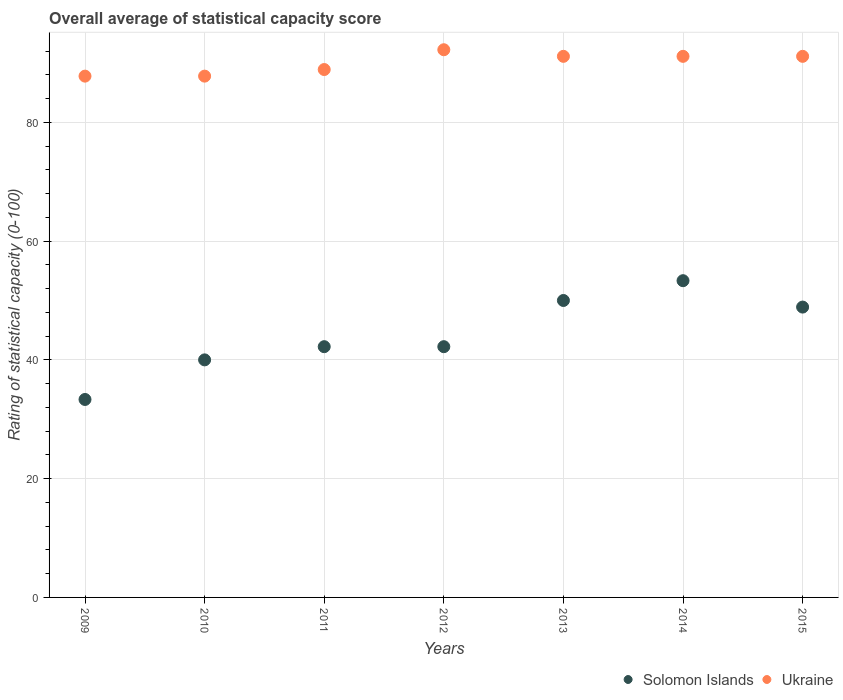What is the rating of statistical capacity in Solomon Islands in 2014?
Your answer should be very brief. 53.33. Across all years, what is the maximum rating of statistical capacity in Solomon Islands?
Provide a short and direct response. 53.33. Across all years, what is the minimum rating of statistical capacity in Ukraine?
Offer a very short reply. 87.78. In which year was the rating of statistical capacity in Solomon Islands maximum?
Make the answer very short. 2014. In which year was the rating of statistical capacity in Solomon Islands minimum?
Your response must be concise. 2009. What is the total rating of statistical capacity in Solomon Islands in the graph?
Provide a succinct answer. 310. What is the difference between the rating of statistical capacity in Solomon Islands in 2011 and that in 2013?
Your answer should be compact. -7.78. What is the difference between the rating of statistical capacity in Ukraine in 2013 and the rating of statistical capacity in Solomon Islands in 2012?
Keep it short and to the point. 48.89. What is the average rating of statistical capacity in Ukraine per year?
Keep it short and to the point. 90. In the year 2010, what is the difference between the rating of statistical capacity in Ukraine and rating of statistical capacity in Solomon Islands?
Ensure brevity in your answer.  47.78. What is the ratio of the rating of statistical capacity in Solomon Islands in 2011 to that in 2014?
Give a very brief answer. 0.79. What is the difference between the highest and the second highest rating of statistical capacity in Solomon Islands?
Provide a short and direct response. 3.33. What is the difference between the highest and the lowest rating of statistical capacity in Solomon Islands?
Keep it short and to the point. 20. In how many years, is the rating of statistical capacity in Ukraine greater than the average rating of statistical capacity in Ukraine taken over all years?
Your answer should be very brief. 4. Is the sum of the rating of statistical capacity in Solomon Islands in 2010 and 2013 greater than the maximum rating of statistical capacity in Ukraine across all years?
Offer a terse response. No. Is the rating of statistical capacity in Ukraine strictly less than the rating of statistical capacity in Solomon Islands over the years?
Give a very brief answer. No. How many dotlines are there?
Make the answer very short. 2. Are the values on the major ticks of Y-axis written in scientific E-notation?
Keep it short and to the point. No. Does the graph contain any zero values?
Give a very brief answer. No. What is the title of the graph?
Offer a very short reply. Overall average of statistical capacity score. What is the label or title of the X-axis?
Provide a short and direct response. Years. What is the label or title of the Y-axis?
Ensure brevity in your answer.  Rating of statistical capacity (0-100). What is the Rating of statistical capacity (0-100) in Solomon Islands in 2009?
Offer a terse response. 33.33. What is the Rating of statistical capacity (0-100) in Ukraine in 2009?
Your answer should be very brief. 87.78. What is the Rating of statistical capacity (0-100) in Solomon Islands in 2010?
Offer a terse response. 40. What is the Rating of statistical capacity (0-100) in Ukraine in 2010?
Provide a short and direct response. 87.78. What is the Rating of statistical capacity (0-100) in Solomon Islands in 2011?
Your answer should be very brief. 42.22. What is the Rating of statistical capacity (0-100) in Ukraine in 2011?
Your answer should be compact. 88.89. What is the Rating of statistical capacity (0-100) in Solomon Islands in 2012?
Provide a short and direct response. 42.22. What is the Rating of statistical capacity (0-100) in Ukraine in 2012?
Keep it short and to the point. 92.22. What is the Rating of statistical capacity (0-100) in Ukraine in 2013?
Your response must be concise. 91.11. What is the Rating of statistical capacity (0-100) of Solomon Islands in 2014?
Your answer should be compact. 53.33. What is the Rating of statistical capacity (0-100) in Ukraine in 2014?
Offer a terse response. 91.11. What is the Rating of statistical capacity (0-100) in Solomon Islands in 2015?
Ensure brevity in your answer.  48.89. What is the Rating of statistical capacity (0-100) of Ukraine in 2015?
Your answer should be compact. 91.11. Across all years, what is the maximum Rating of statistical capacity (0-100) in Solomon Islands?
Keep it short and to the point. 53.33. Across all years, what is the maximum Rating of statistical capacity (0-100) of Ukraine?
Keep it short and to the point. 92.22. Across all years, what is the minimum Rating of statistical capacity (0-100) in Solomon Islands?
Provide a short and direct response. 33.33. Across all years, what is the minimum Rating of statistical capacity (0-100) in Ukraine?
Provide a succinct answer. 87.78. What is the total Rating of statistical capacity (0-100) of Solomon Islands in the graph?
Your response must be concise. 310. What is the total Rating of statistical capacity (0-100) in Ukraine in the graph?
Give a very brief answer. 630. What is the difference between the Rating of statistical capacity (0-100) of Solomon Islands in 2009 and that in 2010?
Your answer should be very brief. -6.67. What is the difference between the Rating of statistical capacity (0-100) of Ukraine in 2009 and that in 2010?
Your response must be concise. 0. What is the difference between the Rating of statistical capacity (0-100) in Solomon Islands in 2009 and that in 2011?
Make the answer very short. -8.89. What is the difference between the Rating of statistical capacity (0-100) in Ukraine in 2009 and that in 2011?
Give a very brief answer. -1.11. What is the difference between the Rating of statistical capacity (0-100) of Solomon Islands in 2009 and that in 2012?
Keep it short and to the point. -8.89. What is the difference between the Rating of statistical capacity (0-100) of Ukraine in 2009 and that in 2012?
Provide a short and direct response. -4.44. What is the difference between the Rating of statistical capacity (0-100) of Solomon Islands in 2009 and that in 2013?
Offer a terse response. -16.67. What is the difference between the Rating of statistical capacity (0-100) of Solomon Islands in 2009 and that in 2014?
Make the answer very short. -20. What is the difference between the Rating of statistical capacity (0-100) in Solomon Islands in 2009 and that in 2015?
Give a very brief answer. -15.56. What is the difference between the Rating of statistical capacity (0-100) of Solomon Islands in 2010 and that in 2011?
Your answer should be compact. -2.22. What is the difference between the Rating of statistical capacity (0-100) of Ukraine in 2010 and that in 2011?
Make the answer very short. -1.11. What is the difference between the Rating of statistical capacity (0-100) in Solomon Islands in 2010 and that in 2012?
Offer a terse response. -2.22. What is the difference between the Rating of statistical capacity (0-100) of Ukraine in 2010 and that in 2012?
Your answer should be compact. -4.44. What is the difference between the Rating of statistical capacity (0-100) of Solomon Islands in 2010 and that in 2014?
Your response must be concise. -13.33. What is the difference between the Rating of statistical capacity (0-100) in Solomon Islands in 2010 and that in 2015?
Make the answer very short. -8.89. What is the difference between the Rating of statistical capacity (0-100) of Ukraine in 2010 and that in 2015?
Offer a very short reply. -3.33. What is the difference between the Rating of statistical capacity (0-100) in Solomon Islands in 2011 and that in 2013?
Provide a succinct answer. -7.78. What is the difference between the Rating of statistical capacity (0-100) of Ukraine in 2011 and that in 2013?
Offer a terse response. -2.22. What is the difference between the Rating of statistical capacity (0-100) in Solomon Islands in 2011 and that in 2014?
Your answer should be compact. -11.11. What is the difference between the Rating of statistical capacity (0-100) in Ukraine in 2011 and that in 2014?
Keep it short and to the point. -2.22. What is the difference between the Rating of statistical capacity (0-100) in Solomon Islands in 2011 and that in 2015?
Ensure brevity in your answer.  -6.67. What is the difference between the Rating of statistical capacity (0-100) of Ukraine in 2011 and that in 2015?
Make the answer very short. -2.22. What is the difference between the Rating of statistical capacity (0-100) of Solomon Islands in 2012 and that in 2013?
Your response must be concise. -7.78. What is the difference between the Rating of statistical capacity (0-100) in Ukraine in 2012 and that in 2013?
Offer a terse response. 1.11. What is the difference between the Rating of statistical capacity (0-100) in Solomon Islands in 2012 and that in 2014?
Offer a terse response. -11.11. What is the difference between the Rating of statistical capacity (0-100) in Solomon Islands in 2012 and that in 2015?
Keep it short and to the point. -6.67. What is the difference between the Rating of statistical capacity (0-100) in Ukraine in 2012 and that in 2015?
Provide a short and direct response. 1.11. What is the difference between the Rating of statistical capacity (0-100) of Solomon Islands in 2013 and that in 2014?
Provide a short and direct response. -3.33. What is the difference between the Rating of statistical capacity (0-100) of Solomon Islands in 2013 and that in 2015?
Offer a terse response. 1.11. What is the difference between the Rating of statistical capacity (0-100) in Solomon Islands in 2014 and that in 2015?
Give a very brief answer. 4.44. What is the difference between the Rating of statistical capacity (0-100) in Solomon Islands in 2009 and the Rating of statistical capacity (0-100) in Ukraine in 2010?
Make the answer very short. -54.44. What is the difference between the Rating of statistical capacity (0-100) in Solomon Islands in 2009 and the Rating of statistical capacity (0-100) in Ukraine in 2011?
Keep it short and to the point. -55.56. What is the difference between the Rating of statistical capacity (0-100) in Solomon Islands in 2009 and the Rating of statistical capacity (0-100) in Ukraine in 2012?
Your response must be concise. -58.89. What is the difference between the Rating of statistical capacity (0-100) of Solomon Islands in 2009 and the Rating of statistical capacity (0-100) of Ukraine in 2013?
Provide a short and direct response. -57.78. What is the difference between the Rating of statistical capacity (0-100) in Solomon Islands in 2009 and the Rating of statistical capacity (0-100) in Ukraine in 2014?
Your answer should be very brief. -57.78. What is the difference between the Rating of statistical capacity (0-100) in Solomon Islands in 2009 and the Rating of statistical capacity (0-100) in Ukraine in 2015?
Offer a terse response. -57.78. What is the difference between the Rating of statistical capacity (0-100) of Solomon Islands in 2010 and the Rating of statistical capacity (0-100) of Ukraine in 2011?
Your response must be concise. -48.89. What is the difference between the Rating of statistical capacity (0-100) in Solomon Islands in 2010 and the Rating of statistical capacity (0-100) in Ukraine in 2012?
Provide a succinct answer. -52.22. What is the difference between the Rating of statistical capacity (0-100) of Solomon Islands in 2010 and the Rating of statistical capacity (0-100) of Ukraine in 2013?
Your answer should be very brief. -51.11. What is the difference between the Rating of statistical capacity (0-100) in Solomon Islands in 2010 and the Rating of statistical capacity (0-100) in Ukraine in 2014?
Your answer should be compact. -51.11. What is the difference between the Rating of statistical capacity (0-100) of Solomon Islands in 2010 and the Rating of statistical capacity (0-100) of Ukraine in 2015?
Offer a terse response. -51.11. What is the difference between the Rating of statistical capacity (0-100) in Solomon Islands in 2011 and the Rating of statistical capacity (0-100) in Ukraine in 2012?
Give a very brief answer. -50. What is the difference between the Rating of statistical capacity (0-100) of Solomon Islands in 2011 and the Rating of statistical capacity (0-100) of Ukraine in 2013?
Offer a terse response. -48.89. What is the difference between the Rating of statistical capacity (0-100) in Solomon Islands in 2011 and the Rating of statistical capacity (0-100) in Ukraine in 2014?
Ensure brevity in your answer.  -48.89. What is the difference between the Rating of statistical capacity (0-100) of Solomon Islands in 2011 and the Rating of statistical capacity (0-100) of Ukraine in 2015?
Your answer should be very brief. -48.89. What is the difference between the Rating of statistical capacity (0-100) of Solomon Islands in 2012 and the Rating of statistical capacity (0-100) of Ukraine in 2013?
Provide a succinct answer. -48.89. What is the difference between the Rating of statistical capacity (0-100) in Solomon Islands in 2012 and the Rating of statistical capacity (0-100) in Ukraine in 2014?
Keep it short and to the point. -48.89. What is the difference between the Rating of statistical capacity (0-100) of Solomon Islands in 2012 and the Rating of statistical capacity (0-100) of Ukraine in 2015?
Provide a succinct answer. -48.89. What is the difference between the Rating of statistical capacity (0-100) in Solomon Islands in 2013 and the Rating of statistical capacity (0-100) in Ukraine in 2014?
Keep it short and to the point. -41.11. What is the difference between the Rating of statistical capacity (0-100) of Solomon Islands in 2013 and the Rating of statistical capacity (0-100) of Ukraine in 2015?
Offer a very short reply. -41.11. What is the difference between the Rating of statistical capacity (0-100) of Solomon Islands in 2014 and the Rating of statistical capacity (0-100) of Ukraine in 2015?
Provide a succinct answer. -37.78. What is the average Rating of statistical capacity (0-100) in Solomon Islands per year?
Offer a terse response. 44.29. In the year 2009, what is the difference between the Rating of statistical capacity (0-100) of Solomon Islands and Rating of statistical capacity (0-100) of Ukraine?
Your answer should be very brief. -54.44. In the year 2010, what is the difference between the Rating of statistical capacity (0-100) in Solomon Islands and Rating of statistical capacity (0-100) in Ukraine?
Offer a very short reply. -47.78. In the year 2011, what is the difference between the Rating of statistical capacity (0-100) of Solomon Islands and Rating of statistical capacity (0-100) of Ukraine?
Your response must be concise. -46.67. In the year 2012, what is the difference between the Rating of statistical capacity (0-100) in Solomon Islands and Rating of statistical capacity (0-100) in Ukraine?
Your response must be concise. -50. In the year 2013, what is the difference between the Rating of statistical capacity (0-100) of Solomon Islands and Rating of statistical capacity (0-100) of Ukraine?
Give a very brief answer. -41.11. In the year 2014, what is the difference between the Rating of statistical capacity (0-100) in Solomon Islands and Rating of statistical capacity (0-100) in Ukraine?
Your response must be concise. -37.78. In the year 2015, what is the difference between the Rating of statistical capacity (0-100) of Solomon Islands and Rating of statistical capacity (0-100) of Ukraine?
Make the answer very short. -42.22. What is the ratio of the Rating of statistical capacity (0-100) in Solomon Islands in 2009 to that in 2010?
Make the answer very short. 0.83. What is the ratio of the Rating of statistical capacity (0-100) in Solomon Islands in 2009 to that in 2011?
Offer a very short reply. 0.79. What is the ratio of the Rating of statistical capacity (0-100) in Ukraine in 2009 to that in 2011?
Provide a succinct answer. 0.99. What is the ratio of the Rating of statistical capacity (0-100) in Solomon Islands in 2009 to that in 2012?
Ensure brevity in your answer.  0.79. What is the ratio of the Rating of statistical capacity (0-100) of Ukraine in 2009 to that in 2012?
Give a very brief answer. 0.95. What is the ratio of the Rating of statistical capacity (0-100) in Ukraine in 2009 to that in 2013?
Offer a very short reply. 0.96. What is the ratio of the Rating of statistical capacity (0-100) of Ukraine in 2009 to that in 2014?
Offer a very short reply. 0.96. What is the ratio of the Rating of statistical capacity (0-100) of Solomon Islands in 2009 to that in 2015?
Ensure brevity in your answer.  0.68. What is the ratio of the Rating of statistical capacity (0-100) of Ukraine in 2009 to that in 2015?
Your response must be concise. 0.96. What is the ratio of the Rating of statistical capacity (0-100) in Ukraine in 2010 to that in 2011?
Offer a very short reply. 0.99. What is the ratio of the Rating of statistical capacity (0-100) of Solomon Islands in 2010 to that in 2012?
Your answer should be very brief. 0.95. What is the ratio of the Rating of statistical capacity (0-100) in Ukraine in 2010 to that in 2012?
Make the answer very short. 0.95. What is the ratio of the Rating of statistical capacity (0-100) of Solomon Islands in 2010 to that in 2013?
Give a very brief answer. 0.8. What is the ratio of the Rating of statistical capacity (0-100) in Ukraine in 2010 to that in 2013?
Provide a short and direct response. 0.96. What is the ratio of the Rating of statistical capacity (0-100) of Ukraine in 2010 to that in 2014?
Keep it short and to the point. 0.96. What is the ratio of the Rating of statistical capacity (0-100) of Solomon Islands in 2010 to that in 2015?
Your response must be concise. 0.82. What is the ratio of the Rating of statistical capacity (0-100) of Ukraine in 2010 to that in 2015?
Provide a succinct answer. 0.96. What is the ratio of the Rating of statistical capacity (0-100) in Ukraine in 2011 to that in 2012?
Provide a short and direct response. 0.96. What is the ratio of the Rating of statistical capacity (0-100) in Solomon Islands in 2011 to that in 2013?
Offer a very short reply. 0.84. What is the ratio of the Rating of statistical capacity (0-100) in Ukraine in 2011 to that in 2013?
Provide a short and direct response. 0.98. What is the ratio of the Rating of statistical capacity (0-100) of Solomon Islands in 2011 to that in 2014?
Provide a short and direct response. 0.79. What is the ratio of the Rating of statistical capacity (0-100) in Ukraine in 2011 to that in 2014?
Your answer should be very brief. 0.98. What is the ratio of the Rating of statistical capacity (0-100) in Solomon Islands in 2011 to that in 2015?
Your answer should be compact. 0.86. What is the ratio of the Rating of statistical capacity (0-100) in Ukraine in 2011 to that in 2015?
Keep it short and to the point. 0.98. What is the ratio of the Rating of statistical capacity (0-100) in Solomon Islands in 2012 to that in 2013?
Make the answer very short. 0.84. What is the ratio of the Rating of statistical capacity (0-100) of Ukraine in 2012 to that in 2013?
Make the answer very short. 1.01. What is the ratio of the Rating of statistical capacity (0-100) of Solomon Islands in 2012 to that in 2014?
Your answer should be compact. 0.79. What is the ratio of the Rating of statistical capacity (0-100) in Ukraine in 2012 to that in 2014?
Your response must be concise. 1.01. What is the ratio of the Rating of statistical capacity (0-100) of Solomon Islands in 2012 to that in 2015?
Give a very brief answer. 0.86. What is the ratio of the Rating of statistical capacity (0-100) of Ukraine in 2012 to that in 2015?
Your answer should be compact. 1.01. What is the ratio of the Rating of statistical capacity (0-100) in Ukraine in 2013 to that in 2014?
Offer a terse response. 1. What is the ratio of the Rating of statistical capacity (0-100) of Solomon Islands in 2013 to that in 2015?
Provide a succinct answer. 1.02. What is the ratio of the Rating of statistical capacity (0-100) in Ukraine in 2013 to that in 2015?
Keep it short and to the point. 1. What is the ratio of the Rating of statistical capacity (0-100) in Solomon Islands in 2014 to that in 2015?
Offer a very short reply. 1.09. What is the difference between the highest and the second highest Rating of statistical capacity (0-100) of Solomon Islands?
Offer a very short reply. 3.33. What is the difference between the highest and the lowest Rating of statistical capacity (0-100) in Ukraine?
Ensure brevity in your answer.  4.44. 